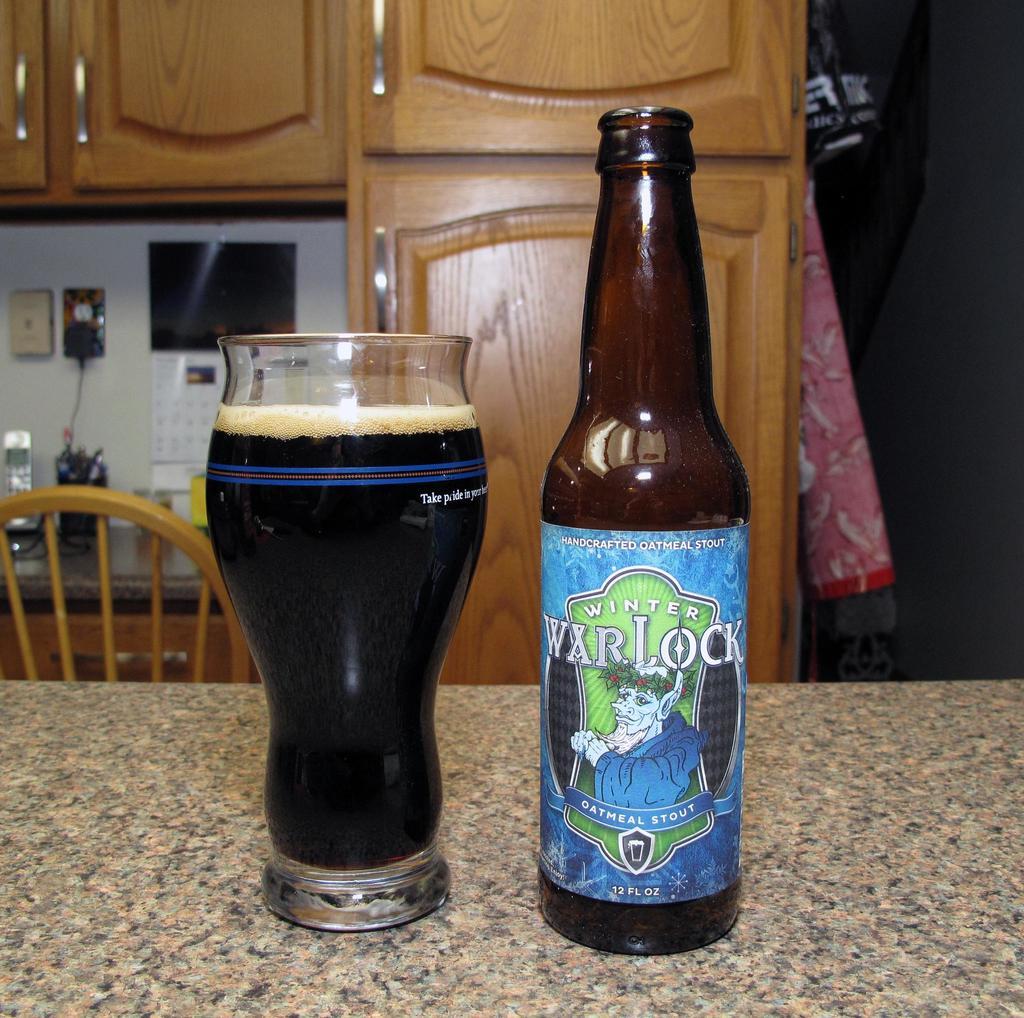How many fluid ounces of beer does the bottle hold?
Offer a terse response. 12. 